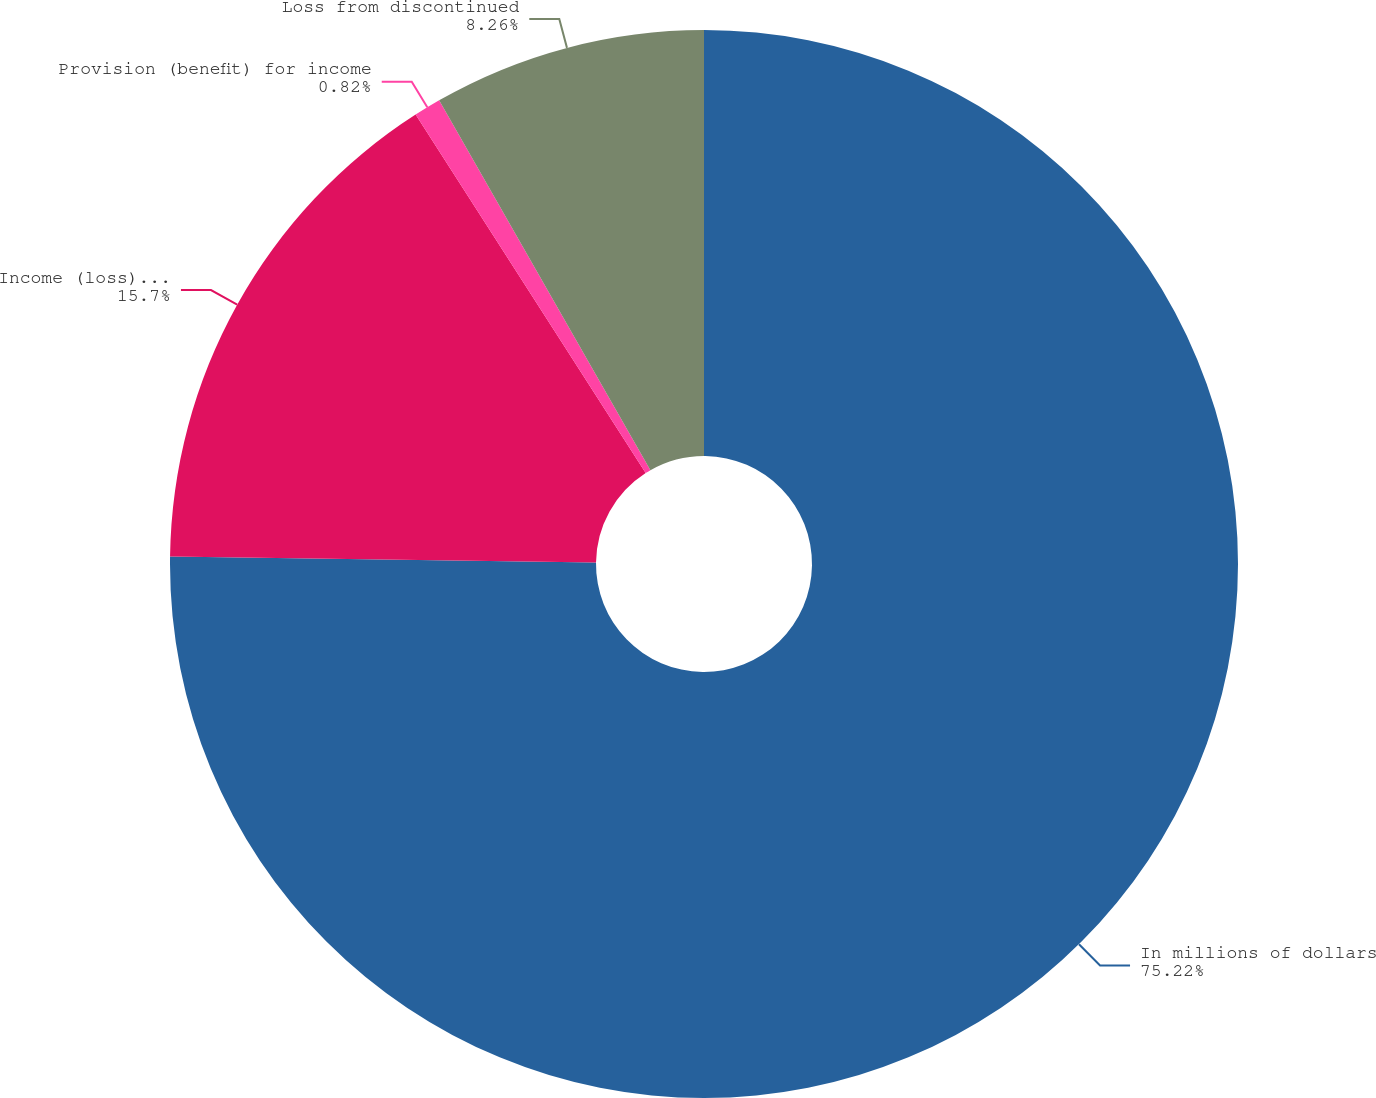Convert chart to OTSL. <chart><loc_0><loc_0><loc_500><loc_500><pie_chart><fcel>In millions of dollars<fcel>Income (loss) from<fcel>Provision (benefit) for income<fcel>Loss from discontinued<nl><fcel>75.22%<fcel>15.7%<fcel>0.82%<fcel>8.26%<nl></chart> 